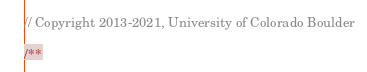<code> <loc_0><loc_0><loc_500><loc_500><_JavaScript_>// Copyright 2013-2021, University of Colorado Boulder

/**</code> 